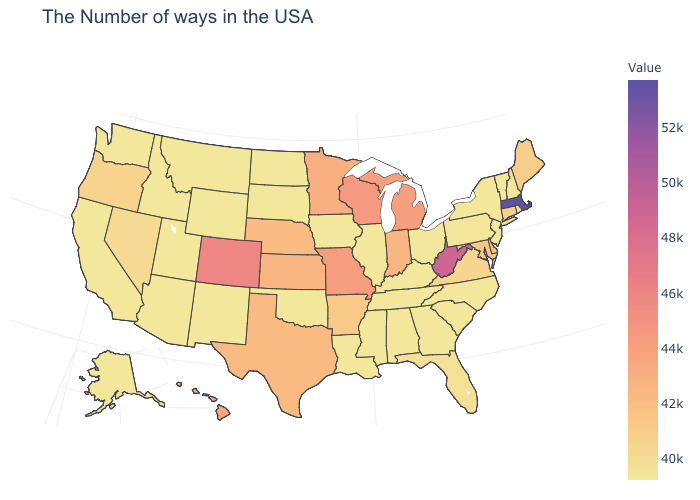Which states have the lowest value in the USA?
Concise answer only. Rhode Island, New Hampshire, Vermont, New York, New Jersey, North Carolina, South Carolina, Ohio, Georgia, Kentucky, Alabama, Tennessee, Illinois, Mississippi, Louisiana, Iowa, Oklahoma, South Dakota, North Dakota, Wyoming, New Mexico, Utah, Montana, Arizona, Idaho, California, Washington, Alaska. Which states have the highest value in the USA?
Give a very brief answer. Massachusetts. Does Massachusetts have the highest value in the USA?
Quick response, please. Yes. 